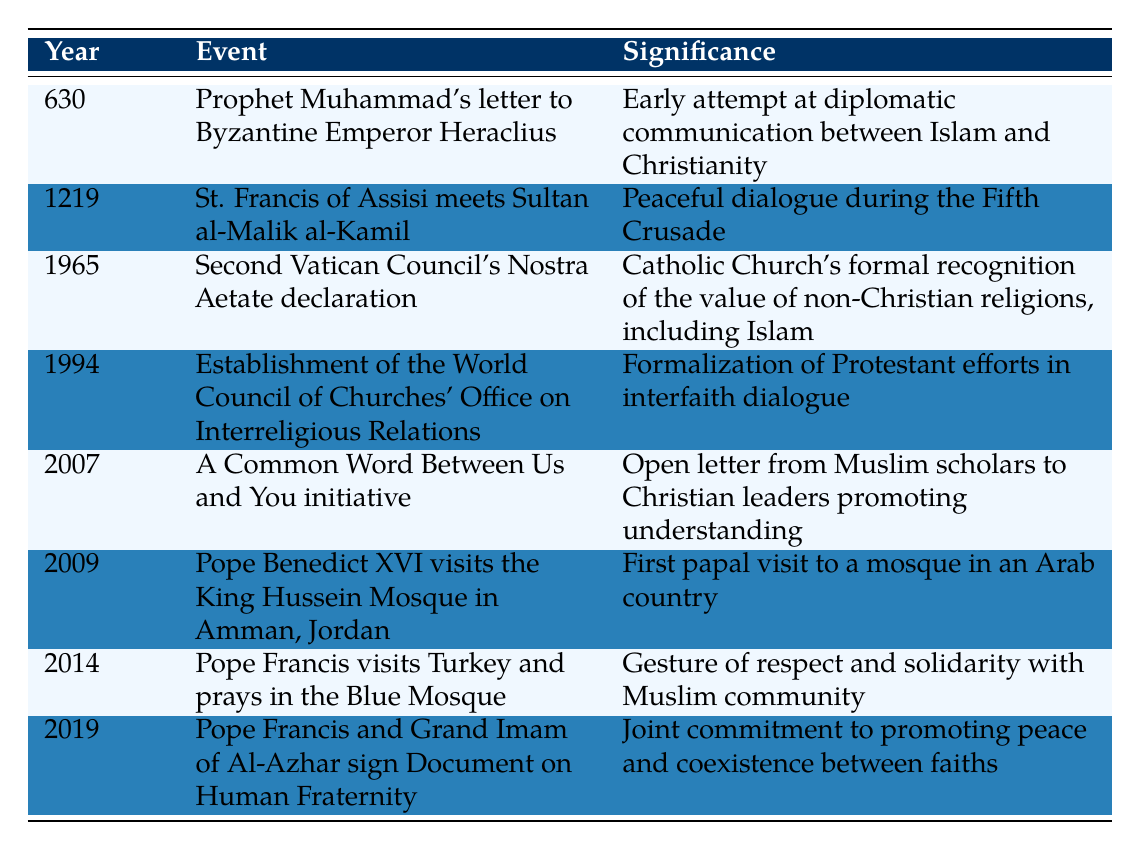What year did St. Francis of Assisi meet Sultan al-Malik al-Kamil? The table lists the event along with its corresponding year, showing that St. Francis of Assisi met Sultan al-Malik al-Kamil in the year 1219.
Answer: 1219 What is the significance of the Second Vatican Council's Nostra Aetate declaration? The table provides the significance of this event, stating it was the Catholic Church's formal recognition of the value of non-Christian religions, including Islam.
Answer: Catholic Church's recognition of non-Christian religions How many events occurred before the year 2000? By counting the events listed in the table that have years before 2000, there are 6 events (630, 1219, 1965, 1994, 2007, 2009).
Answer: 6 Did Pope Benedict XVI's visit to the King Hussein Mosque occur before 2010? The table shows that Pope Benedict XVI visited the mosque in 2009, which is indeed before 2010.
Answer: Yes What is the earliest event listed in the table? The table indicates the earliest event year is 630, which corresponds to Prophet Muhammad's letter to Byzantine Emperor Heraclius.
Answer: 630 How many events involved the Pope, and what percentage of the total events does that represent? The table indicates there are 3 events involving the Pope (2009, 2014, 2019). There are a total of 8 events, so (3/8)*100 = 37.5%.
Answer: 3 events, 37.5% What was the first recorded dialogue attempts between Islam and Christianity according to the table? The table states that the first recorded attempt was Prophet Muhammad's letter to Byzantine Emperor Heraclius in 630.
Answer: Prophet Muhammad's letter Which event in 2019 signifies a joint commitment to promoting peace between faiths? The table notes that in 2019, Pope Francis and the Grand Imam of Al-Azhar signed a Document on Human Fraternity, which signifies this commitment to peace.
Answer: Document on Human Fraternity How does the significance of the 2007 event compare to the significance of the 1965 event regarding scholarly interaction? The 2007 event represents an open letter from Muslim scholars to Christian leaders, while the 1965 event marks formal recognition by the Catholic Church of non-Christian religions. This shows a shift from acknowledgment to proactive engagement.
Answer: Shift from acknowledgment to proactive engagement What was the primary focus of St. Francis of Assisi's meeting with Sultan al-Malik al-Kamil? The significance mentioned in the table highlights that their meeting was a peaceful dialogue during the Fifth Crusade.
Answer: Peaceful dialogue during the Fifth Crusade 